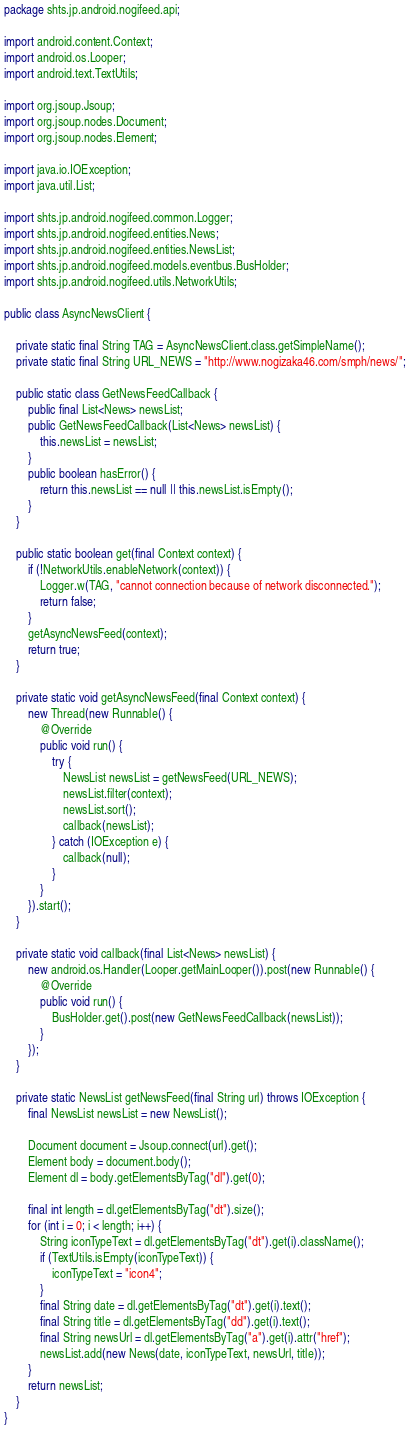Convert code to text. <code><loc_0><loc_0><loc_500><loc_500><_Java_>package shts.jp.android.nogifeed.api;

import android.content.Context;
import android.os.Looper;
import android.text.TextUtils;

import org.jsoup.Jsoup;
import org.jsoup.nodes.Document;
import org.jsoup.nodes.Element;

import java.io.IOException;
import java.util.List;

import shts.jp.android.nogifeed.common.Logger;
import shts.jp.android.nogifeed.entities.News;
import shts.jp.android.nogifeed.entities.NewsList;
import shts.jp.android.nogifeed.models.eventbus.BusHolder;
import shts.jp.android.nogifeed.utils.NetworkUtils;

public class AsyncNewsClient {

    private static final String TAG = AsyncNewsClient.class.getSimpleName();
    private static final String URL_NEWS = "http://www.nogizaka46.com/smph/news/";

    public static class GetNewsFeedCallback {
        public final List<News> newsList;
        public GetNewsFeedCallback(List<News> newsList) {
            this.newsList = newsList;
        }
        public boolean hasError() {
            return this.newsList == null || this.newsList.isEmpty();
        }
    }

    public static boolean get(final Context context) {
        if (!NetworkUtils.enableNetwork(context)) {
            Logger.w(TAG, "cannot connection because of network disconnected.");
            return false;
        }
        getAsyncNewsFeed(context);
        return true;
    }

    private static void getAsyncNewsFeed(final Context context) {
        new Thread(new Runnable() {
            @Override
            public void run() {
                try {
                    NewsList newsList = getNewsFeed(URL_NEWS);
                    newsList.filter(context);
                    newsList.sort();
                    callback(newsList);
                } catch (IOException e) {
                    callback(null);
                }
            }
        }).start();
    }

    private static void callback(final List<News> newsList) {
        new android.os.Handler(Looper.getMainLooper()).post(new Runnable() {
            @Override
            public void run() {
                BusHolder.get().post(new GetNewsFeedCallback(newsList));
            }
        });
    }

    private static NewsList getNewsFeed(final String url) throws IOException {
        final NewsList newsList = new NewsList();

        Document document = Jsoup.connect(url).get();
        Element body = document.body();
        Element dl = body.getElementsByTag("dl").get(0);

        final int length = dl.getElementsByTag("dt").size();
        for (int i = 0; i < length; i++) {
            String iconTypeText = dl.getElementsByTag("dt").get(i).className();
            if (TextUtils.isEmpty(iconTypeText)) {
                iconTypeText = "icon4";
            }
            final String date = dl.getElementsByTag("dt").get(i).text();
            final String title = dl.getElementsByTag("dd").get(i).text();
            final String newsUrl = dl.getElementsByTag("a").get(i).attr("href");
            newsList.add(new News(date, iconTypeText, newsUrl, title));
        }
        return newsList;
    }
}
</code> 